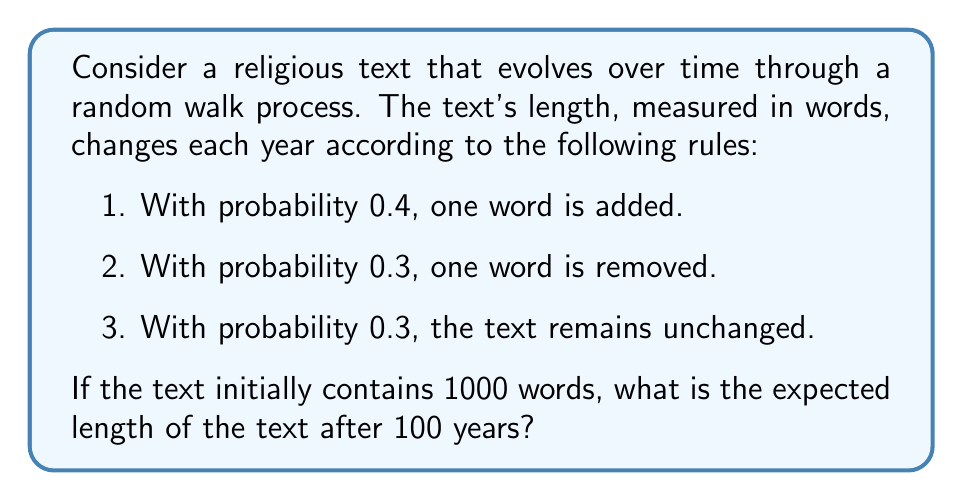Teach me how to tackle this problem. To solve this problem, we'll follow these steps:

1) First, let's calculate the expected change in the number of words per year:

   $E[\text{change}] = 1 \cdot 0.4 + (-1) \cdot 0.3 + 0 \cdot 0.3 = 0.4 - 0.3 = 0.1$

   So, on average, the text gains 0.1 words per year.

2) In a random walk, the expected position after $n$ steps is the initial position plus $n$ times the expected change per step.

3) In this case:
   - Initial position: 1000 words
   - Number of steps (years): 100
   - Expected change per step: 0.1 words

4) Therefore, the expected length after 100 years is:

   $E[\text{length}] = 1000 + 100 \cdot 0.1 = 1000 + 10 = 1010$

Thus, we expect the text to contain 1010 words after 100 years.
Answer: 1010 words 